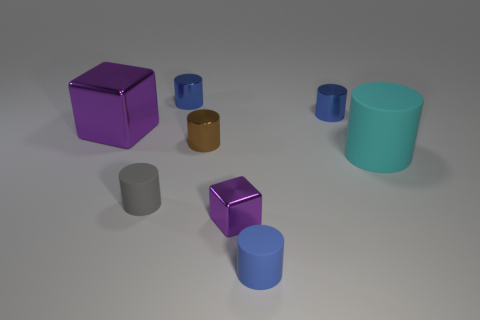Do the tiny blue thing that is in front of the gray matte cylinder and the tiny brown shiny thing have the same shape?
Your answer should be very brief. Yes. The shiny thing that is the same color as the tiny metallic cube is what size?
Ensure brevity in your answer.  Large. Is there a gray object of the same size as the brown object?
Make the answer very short. Yes. Are there any objects to the right of the tiny matte thing in front of the metallic block to the right of the tiny brown metallic thing?
Offer a very short reply. Yes. There is a large metal thing; is its color the same as the metal cube in front of the gray rubber cylinder?
Provide a short and direct response. Yes. What is the small blue cylinder right of the tiny blue cylinder that is in front of the small blue shiny thing that is right of the brown metal cylinder made of?
Make the answer very short. Metal. What is the shape of the large object in front of the small brown thing?
Provide a short and direct response. Cylinder. The cyan cylinder that is made of the same material as the gray thing is what size?
Offer a terse response. Large. What number of gray matte objects are the same shape as the cyan matte thing?
Ensure brevity in your answer.  1. There is a cube that is in front of the small gray cylinder; does it have the same color as the large block?
Your answer should be very brief. Yes. 